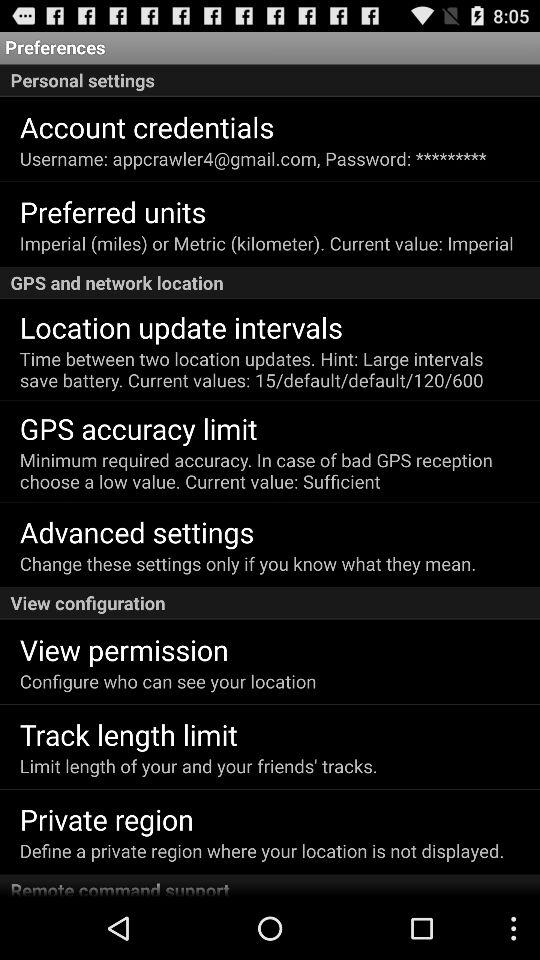What is the username? The username is "appcrawler4@gmail.com". 